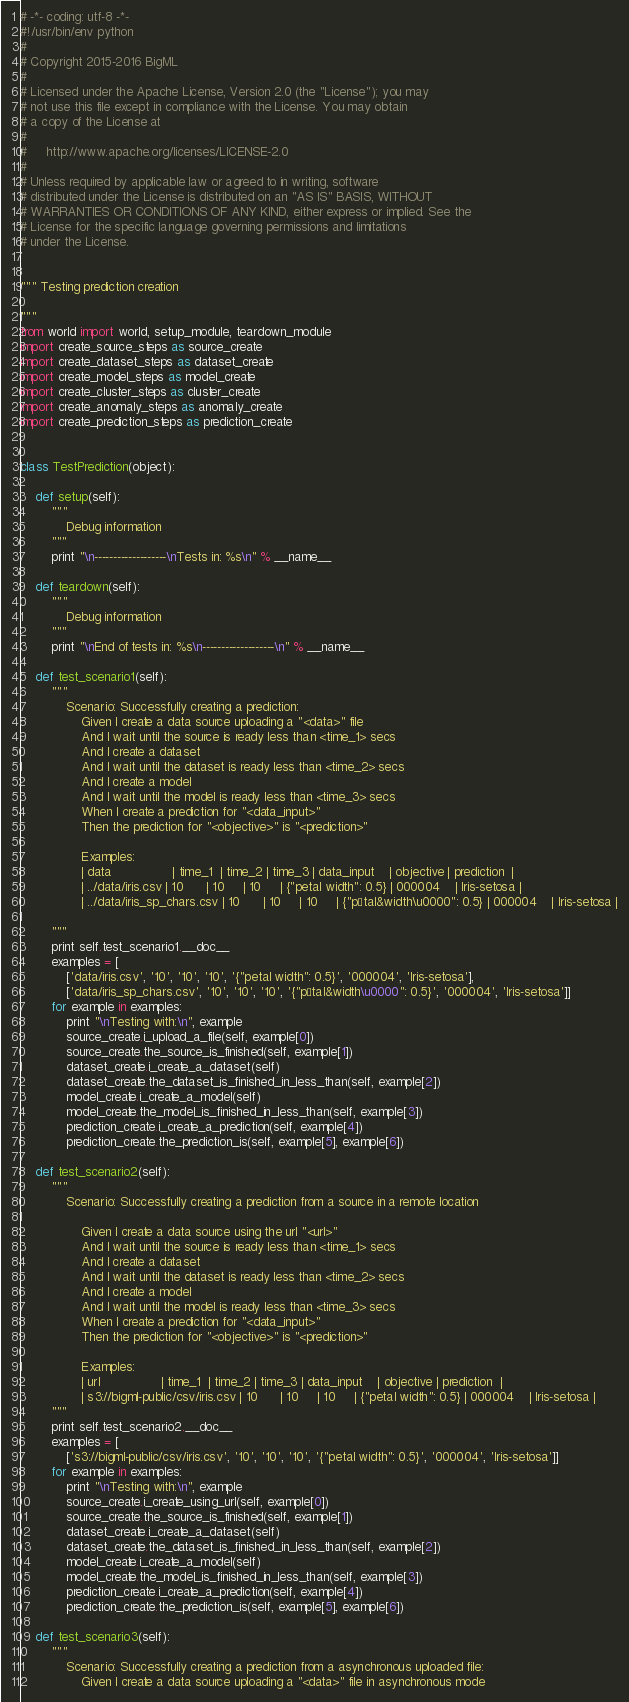<code> <loc_0><loc_0><loc_500><loc_500><_Python_># -*- coding: utf-8 -*-
#!/usr/bin/env python
#
# Copyright 2015-2016 BigML
#
# Licensed under the Apache License, Version 2.0 (the "License"); you may
# not use this file except in compliance with the License. You may obtain
# a copy of the License at
#
#     http://www.apache.org/licenses/LICENSE-2.0
#
# Unless required by applicable law or agreed to in writing, software
# distributed under the License is distributed on an "AS IS" BASIS, WITHOUT
# WARRANTIES OR CONDITIONS OF ANY KIND, either express or implied. See the
# License for the specific language governing permissions and limitations
# under the License.


""" Testing prediction creation

"""
from world import world, setup_module, teardown_module
import create_source_steps as source_create
import create_dataset_steps as dataset_create
import create_model_steps as model_create
import create_cluster_steps as cluster_create
import create_anomaly_steps as anomaly_create
import create_prediction_steps as prediction_create


class TestPrediction(object):

    def setup(self):
        """
            Debug information
        """
        print "\n-------------------\nTests in: %s\n" % __name__

    def teardown(self):
        """
            Debug information
        """
        print "\nEnd of tests in: %s\n-------------------\n" % __name__

    def test_scenario1(self):
        """
            Scenario: Successfully creating a prediction:
                Given I create a data source uploading a "<data>" file
                And I wait until the source is ready less than <time_1> secs
                And I create a dataset
                And I wait until the dataset is ready less than <time_2> secs
                And I create a model
                And I wait until the model is ready less than <time_3> secs
                When I create a prediction for "<data_input>"
                Then the prediction for "<objective>" is "<prediction>"

                Examples:
                | data                | time_1  | time_2 | time_3 | data_input    | objective | prediction  |
                | ../data/iris.csv | 10      | 10     | 10     | {"petal width": 0.5} | 000004    | Iris-setosa |
                | ../data/iris_sp_chars.csv | 10      | 10     | 10     | {"pétal&width\u0000": 0.5} | 000004    | Iris-setosa |

        """
        print self.test_scenario1.__doc__
        examples = [
            ['data/iris.csv', '10', '10', '10', '{"petal width": 0.5}', '000004', 'Iris-setosa'],
            ['data/iris_sp_chars.csv', '10', '10', '10', '{"pétal&width\u0000": 0.5}', '000004', 'Iris-setosa']]
        for example in examples:
            print "\nTesting with:\n", example
            source_create.i_upload_a_file(self, example[0])
            source_create.the_source_is_finished(self, example[1])
            dataset_create.i_create_a_dataset(self)
            dataset_create.the_dataset_is_finished_in_less_than(self, example[2])
            model_create.i_create_a_model(self)
            model_create.the_model_is_finished_in_less_than(self, example[3])
            prediction_create.i_create_a_prediction(self, example[4])
            prediction_create.the_prediction_is(self, example[5], example[6])

    def test_scenario2(self):
        """
            Scenario: Successfully creating a prediction from a source in a remote location

                Given I create a data source using the url "<url>"
                And I wait until the source is ready less than <time_1> secs
                And I create a dataset
                And I wait until the dataset is ready less than <time_2> secs
                And I create a model
                And I wait until the model is ready less than <time_3> secs
                When I create a prediction for "<data_input>"
                Then the prediction for "<objective>" is "<prediction>"

                Examples:
                | url                | time_1  | time_2 | time_3 | data_input    | objective | prediction  |
                | s3://bigml-public/csv/iris.csv | 10      | 10     | 10     | {"petal width": 0.5} | 000004    | Iris-setosa |
        """
        print self.test_scenario2.__doc__
        examples = [
            ['s3://bigml-public/csv/iris.csv', '10', '10', '10', '{"petal width": 0.5}', '000004', 'Iris-setosa']]
        for example in examples:
            print "\nTesting with:\n", example
            source_create.i_create_using_url(self, example[0])
            source_create.the_source_is_finished(self, example[1])
            dataset_create.i_create_a_dataset(self)
            dataset_create.the_dataset_is_finished_in_less_than(self, example[2])
            model_create.i_create_a_model(self)
            model_create.the_model_is_finished_in_less_than(self, example[3])
            prediction_create.i_create_a_prediction(self, example[4])
            prediction_create.the_prediction_is(self, example[5], example[6])

    def test_scenario3(self):
        """
            Scenario: Successfully creating a prediction from a asynchronous uploaded file:
                Given I create a data source uploading a "<data>" file in asynchronous mode</code> 